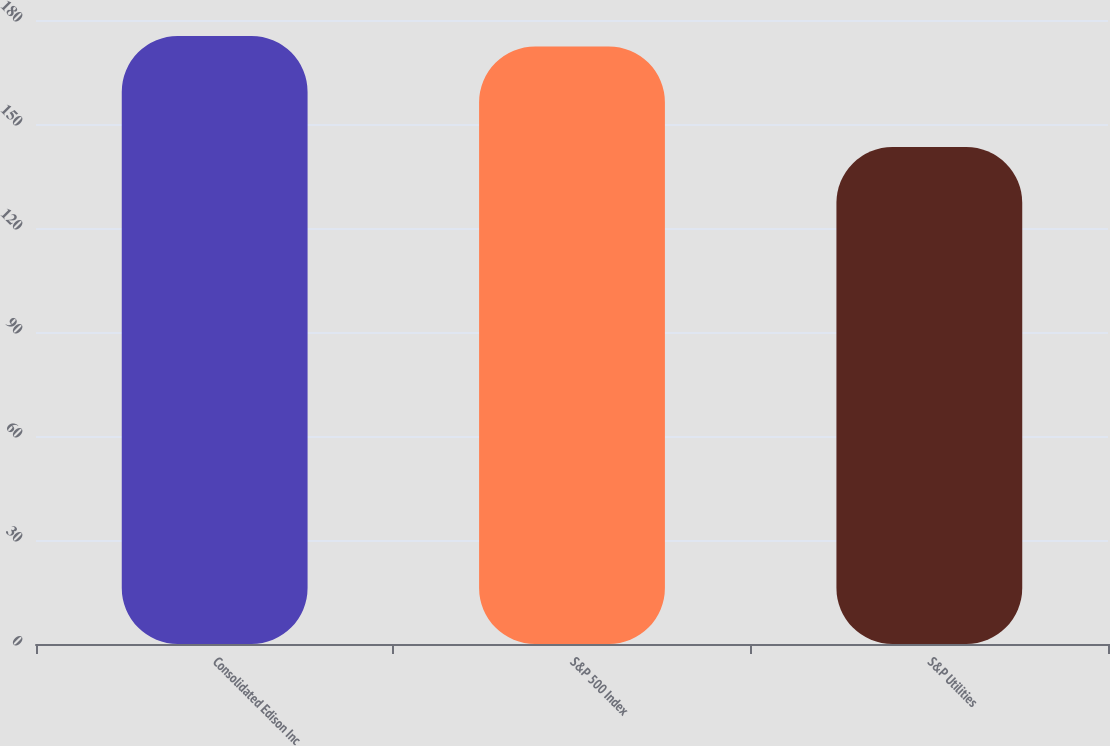Convert chart to OTSL. <chart><loc_0><loc_0><loc_500><loc_500><bar_chart><fcel>Consolidated Edison Inc<fcel>S&P 500 Index<fcel>S&P Utilities<nl><fcel>175.41<fcel>172.37<fcel>143.35<nl></chart> 